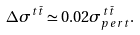<formula> <loc_0><loc_0><loc_500><loc_500>\Delta \sigma ^ { t \bar { t } } \simeq 0 . 0 2 \sigma ^ { t \bar { t } } _ { p e r t } .</formula> 